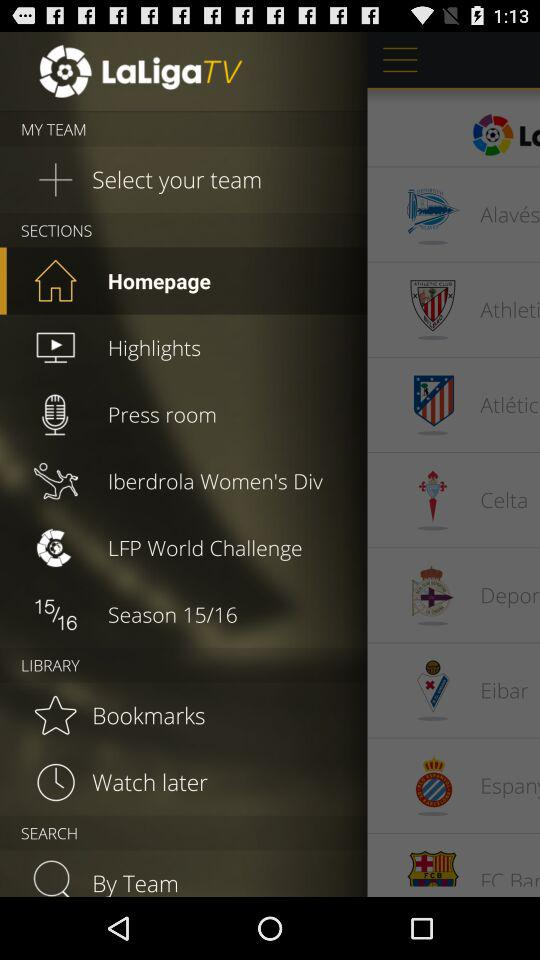What is the application name? The application name is "LaLigaTV". 